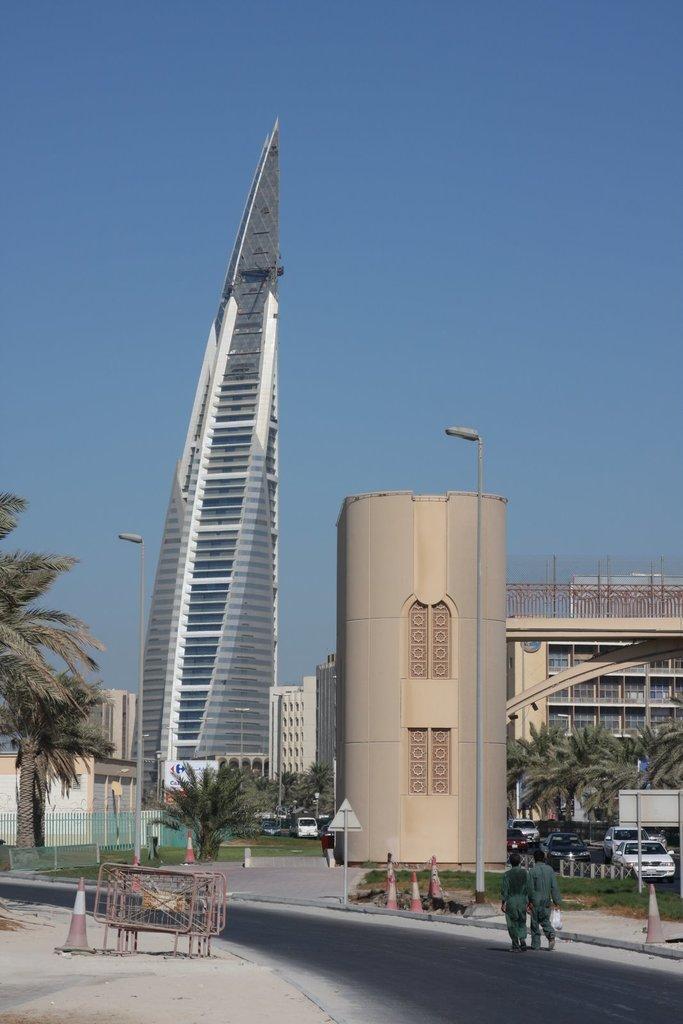Please provide a concise description of this image. In this image we can see two men are walking on the road. In the middle of the image, we can see trees, buildings, cars, traffic cones, sign board and poles. The sky is in white color. In the left bottom of the image we can see pavement, traffic cone and barriers. 